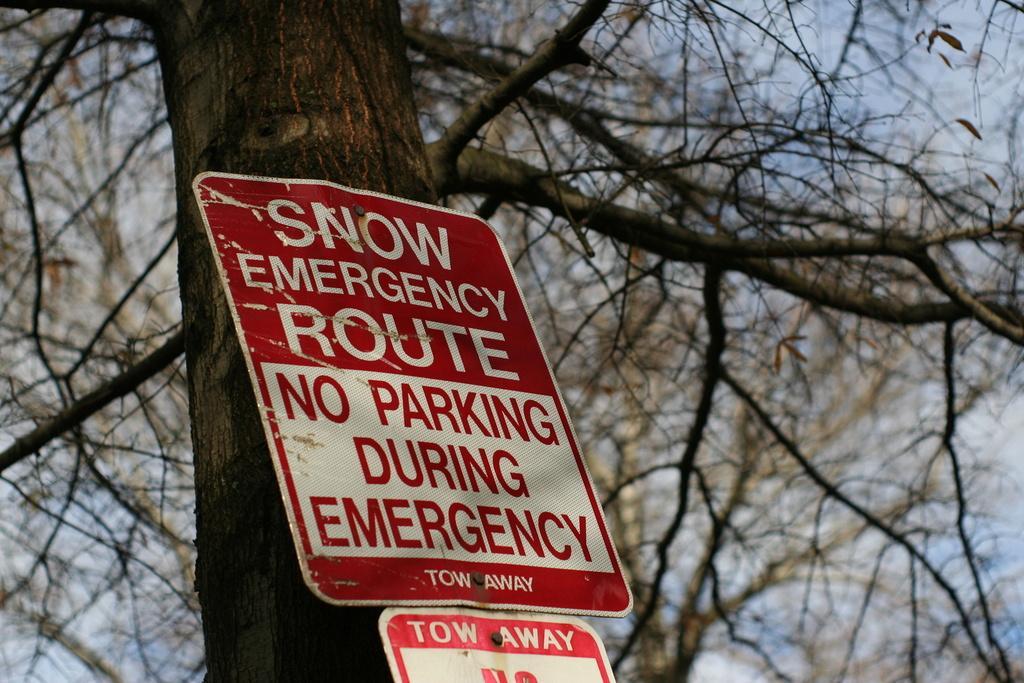Describe this image in one or two sentences. In the center of the image there is a sign board to the tree. In the background there is a sky. 